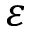<formula> <loc_0><loc_0><loc_500><loc_500>\varepsilon</formula> 